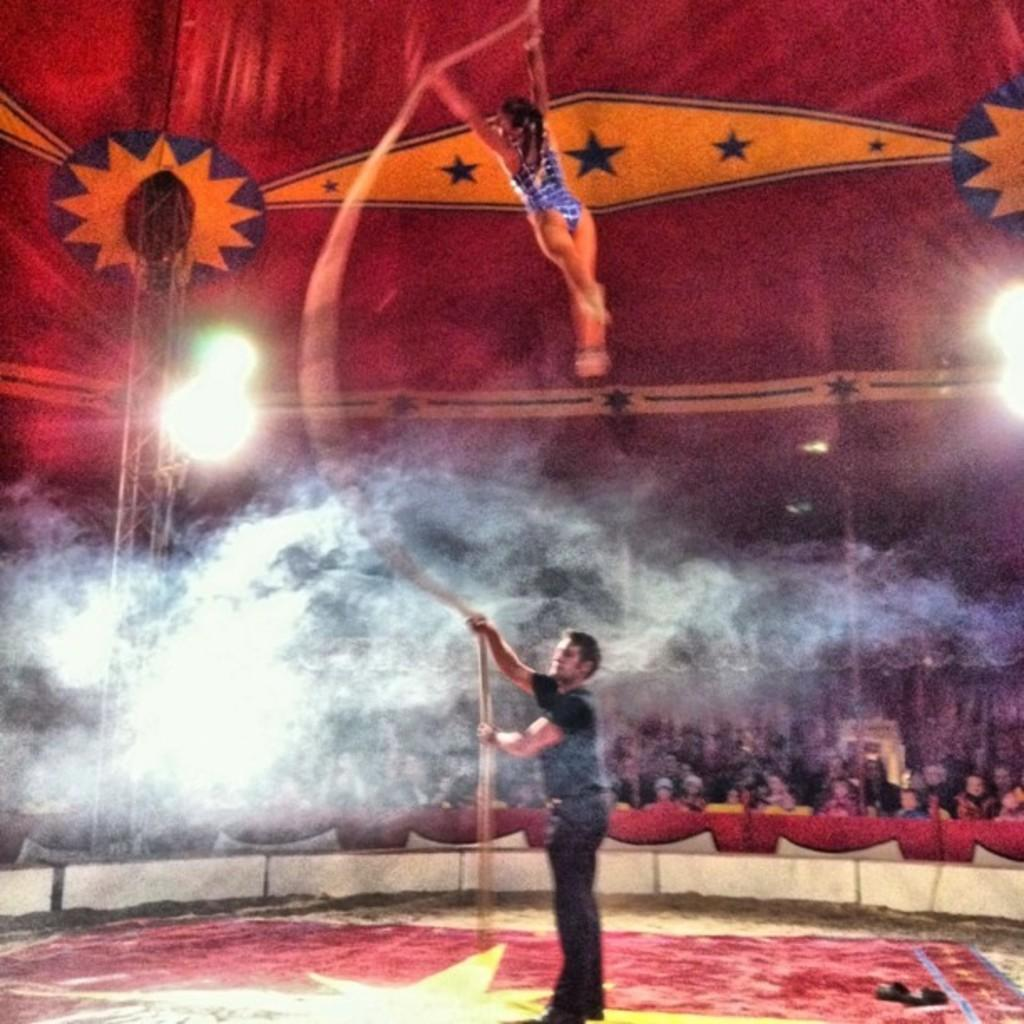What is the main subject of the image? There is a man standing in the image. What is the girl doing in the image? The girl is performing in the image. Can you describe the background of the image? There are people in the background of the image. What can be seen in addition to the people in the image? Lights are visible in the image. What type of fruit is being processed by the machine in the image? There is no machine or fruit present in the image. 